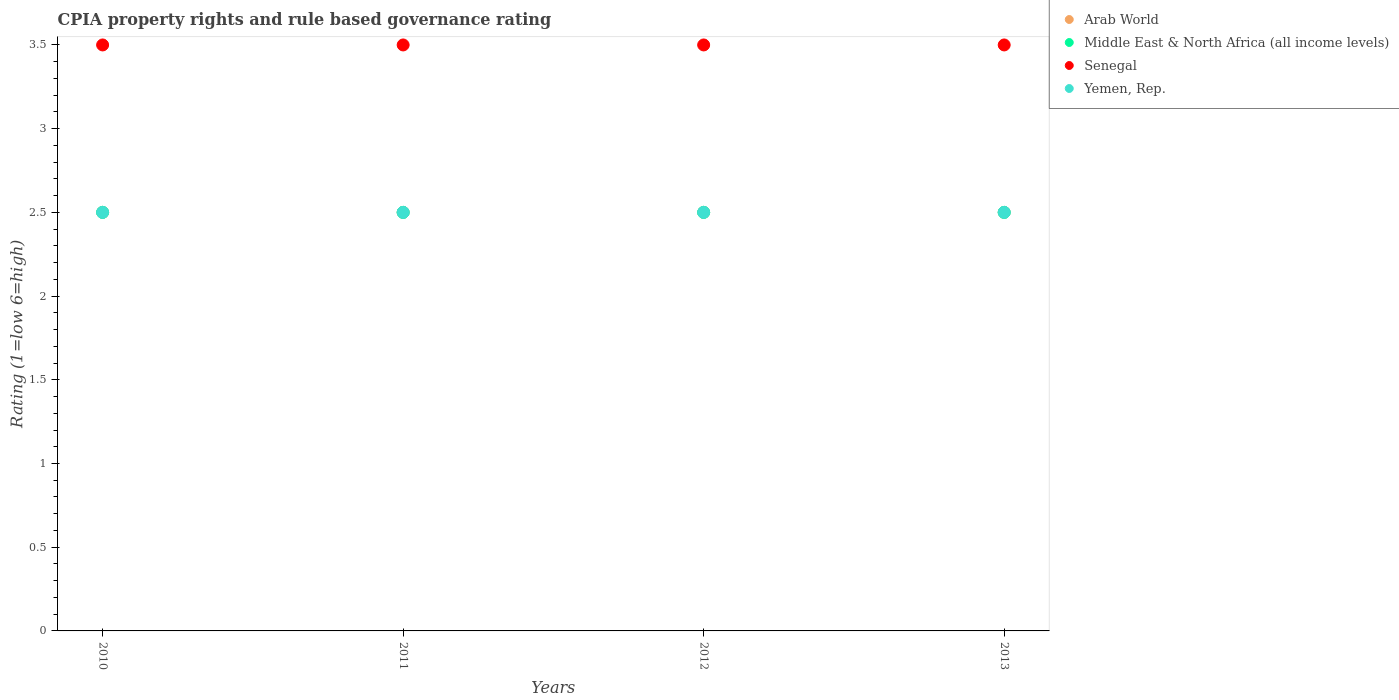Is the number of dotlines equal to the number of legend labels?
Keep it short and to the point. Yes. What is the CPIA rating in Yemen, Rep. in 2011?
Ensure brevity in your answer.  2.5. Across all years, what is the minimum CPIA rating in Senegal?
Ensure brevity in your answer.  3.5. In which year was the CPIA rating in Yemen, Rep. maximum?
Your answer should be compact. 2010. In which year was the CPIA rating in Senegal minimum?
Your answer should be compact. 2010. What is the ratio of the CPIA rating in Arab World in 2012 to that in 2013?
Make the answer very short. 1. Is the CPIA rating in Senegal in 2010 less than that in 2013?
Offer a very short reply. No. Is the difference between the CPIA rating in Yemen, Rep. in 2010 and 2011 greater than the difference between the CPIA rating in Senegal in 2010 and 2011?
Give a very brief answer. No. What is the difference between the highest and the second highest CPIA rating in Middle East & North Africa (all income levels)?
Keep it short and to the point. 0. Is the sum of the CPIA rating in Arab World in 2010 and 2012 greater than the maximum CPIA rating in Yemen, Rep. across all years?
Your answer should be compact. Yes. Does the CPIA rating in Arab World monotonically increase over the years?
Offer a very short reply. No. Is the CPIA rating in Senegal strictly greater than the CPIA rating in Yemen, Rep. over the years?
Ensure brevity in your answer.  Yes. Is the CPIA rating in Senegal strictly less than the CPIA rating in Arab World over the years?
Your response must be concise. No. How many dotlines are there?
Ensure brevity in your answer.  4. Does the graph contain any zero values?
Keep it short and to the point. No. Does the graph contain grids?
Give a very brief answer. No. Where does the legend appear in the graph?
Give a very brief answer. Top right. How many legend labels are there?
Your answer should be compact. 4. How are the legend labels stacked?
Offer a terse response. Vertical. What is the title of the graph?
Keep it short and to the point. CPIA property rights and rule based governance rating. Does "Peru" appear as one of the legend labels in the graph?
Offer a terse response. No. What is the label or title of the Y-axis?
Keep it short and to the point. Rating (1=low 6=high). What is the Rating (1=low 6=high) of Arab World in 2011?
Your response must be concise. 2.5. What is the Rating (1=low 6=high) of Middle East & North Africa (all income levels) in 2011?
Your answer should be compact. 2.5. What is the Rating (1=low 6=high) of Yemen, Rep. in 2011?
Keep it short and to the point. 2.5. What is the Rating (1=low 6=high) of Arab World in 2012?
Keep it short and to the point. 2.5. What is the Rating (1=low 6=high) of Arab World in 2013?
Provide a short and direct response. 2.5. What is the Rating (1=low 6=high) of Middle East & North Africa (all income levels) in 2013?
Give a very brief answer. 2.5. What is the Rating (1=low 6=high) of Senegal in 2013?
Your answer should be compact. 3.5. What is the Rating (1=low 6=high) of Yemen, Rep. in 2013?
Offer a terse response. 2.5. Across all years, what is the maximum Rating (1=low 6=high) of Middle East & North Africa (all income levels)?
Ensure brevity in your answer.  2.5. Across all years, what is the maximum Rating (1=low 6=high) of Senegal?
Provide a succinct answer. 3.5. Across all years, what is the maximum Rating (1=low 6=high) in Yemen, Rep.?
Provide a succinct answer. 2.5. Across all years, what is the minimum Rating (1=low 6=high) in Middle East & North Africa (all income levels)?
Provide a succinct answer. 2.5. Across all years, what is the minimum Rating (1=low 6=high) of Senegal?
Your answer should be very brief. 3.5. Across all years, what is the minimum Rating (1=low 6=high) in Yemen, Rep.?
Make the answer very short. 2.5. What is the total Rating (1=low 6=high) in Arab World in the graph?
Your response must be concise. 10. What is the difference between the Rating (1=low 6=high) of Middle East & North Africa (all income levels) in 2010 and that in 2011?
Offer a very short reply. 0. What is the difference between the Rating (1=low 6=high) of Arab World in 2010 and that in 2013?
Offer a terse response. 0. What is the difference between the Rating (1=low 6=high) of Senegal in 2010 and that in 2013?
Make the answer very short. 0. What is the difference between the Rating (1=low 6=high) in Arab World in 2011 and that in 2012?
Your response must be concise. 0. What is the difference between the Rating (1=low 6=high) of Middle East & North Africa (all income levels) in 2011 and that in 2012?
Your answer should be very brief. 0. What is the difference between the Rating (1=low 6=high) of Senegal in 2011 and that in 2012?
Provide a succinct answer. 0. What is the difference between the Rating (1=low 6=high) in Arab World in 2011 and that in 2013?
Your response must be concise. 0. What is the difference between the Rating (1=low 6=high) of Middle East & North Africa (all income levels) in 2011 and that in 2013?
Your answer should be very brief. 0. What is the difference between the Rating (1=low 6=high) of Senegal in 2011 and that in 2013?
Keep it short and to the point. 0. What is the difference between the Rating (1=low 6=high) of Yemen, Rep. in 2011 and that in 2013?
Your answer should be compact. 0. What is the difference between the Rating (1=low 6=high) of Middle East & North Africa (all income levels) in 2012 and that in 2013?
Offer a very short reply. 0. What is the difference between the Rating (1=low 6=high) of Senegal in 2012 and that in 2013?
Provide a succinct answer. 0. What is the difference between the Rating (1=low 6=high) in Yemen, Rep. in 2012 and that in 2013?
Provide a short and direct response. 0. What is the difference between the Rating (1=low 6=high) of Arab World in 2010 and the Rating (1=low 6=high) of Middle East & North Africa (all income levels) in 2011?
Offer a very short reply. 0. What is the difference between the Rating (1=low 6=high) in Arab World in 2010 and the Rating (1=low 6=high) in Middle East & North Africa (all income levels) in 2012?
Offer a very short reply. 0. What is the difference between the Rating (1=low 6=high) of Arab World in 2010 and the Rating (1=low 6=high) of Senegal in 2012?
Keep it short and to the point. -1. What is the difference between the Rating (1=low 6=high) in Arab World in 2010 and the Rating (1=low 6=high) in Yemen, Rep. in 2012?
Offer a terse response. 0. What is the difference between the Rating (1=low 6=high) of Middle East & North Africa (all income levels) in 2010 and the Rating (1=low 6=high) of Senegal in 2012?
Ensure brevity in your answer.  -1. What is the difference between the Rating (1=low 6=high) in Middle East & North Africa (all income levels) in 2010 and the Rating (1=low 6=high) in Yemen, Rep. in 2012?
Ensure brevity in your answer.  0. What is the difference between the Rating (1=low 6=high) of Senegal in 2010 and the Rating (1=low 6=high) of Yemen, Rep. in 2012?
Provide a short and direct response. 1. What is the difference between the Rating (1=low 6=high) of Arab World in 2010 and the Rating (1=low 6=high) of Yemen, Rep. in 2013?
Your answer should be compact. 0. What is the difference between the Rating (1=low 6=high) in Middle East & North Africa (all income levels) in 2010 and the Rating (1=low 6=high) in Senegal in 2013?
Give a very brief answer. -1. What is the difference between the Rating (1=low 6=high) of Arab World in 2011 and the Rating (1=low 6=high) of Middle East & North Africa (all income levels) in 2012?
Provide a short and direct response. 0. What is the difference between the Rating (1=low 6=high) of Arab World in 2011 and the Rating (1=low 6=high) of Yemen, Rep. in 2012?
Your answer should be very brief. 0. What is the difference between the Rating (1=low 6=high) in Middle East & North Africa (all income levels) in 2011 and the Rating (1=low 6=high) in Senegal in 2012?
Your response must be concise. -1. What is the difference between the Rating (1=low 6=high) in Middle East & North Africa (all income levels) in 2011 and the Rating (1=low 6=high) in Yemen, Rep. in 2012?
Provide a succinct answer. 0. What is the difference between the Rating (1=low 6=high) of Senegal in 2011 and the Rating (1=low 6=high) of Yemen, Rep. in 2012?
Your answer should be very brief. 1. What is the difference between the Rating (1=low 6=high) in Arab World in 2011 and the Rating (1=low 6=high) in Middle East & North Africa (all income levels) in 2013?
Give a very brief answer. 0. What is the difference between the Rating (1=low 6=high) of Middle East & North Africa (all income levels) in 2011 and the Rating (1=low 6=high) of Senegal in 2013?
Your answer should be very brief. -1. What is the difference between the Rating (1=low 6=high) in Middle East & North Africa (all income levels) in 2011 and the Rating (1=low 6=high) in Yemen, Rep. in 2013?
Provide a succinct answer. 0. What is the difference between the Rating (1=low 6=high) in Senegal in 2011 and the Rating (1=low 6=high) in Yemen, Rep. in 2013?
Make the answer very short. 1. What is the difference between the Rating (1=low 6=high) of Arab World in 2012 and the Rating (1=low 6=high) of Yemen, Rep. in 2013?
Offer a terse response. 0. What is the difference between the Rating (1=low 6=high) in Middle East & North Africa (all income levels) in 2012 and the Rating (1=low 6=high) in Senegal in 2013?
Provide a short and direct response. -1. What is the average Rating (1=low 6=high) in Middle East & North Africa (all income levels) per year?
Provide a short and direct response. 2.5. What is the average Rating (1=low 6=high) in Senegal per year?
Keep it short and to the point. 3.5. What is the average Rating (1=low 6=high) in Yemen, Rep. per year?
Keep it short and to the point. 2.5. In the year 2010, what is the difference between the Rating (1=low 6=high) in Arab World and Rating (1=low 6=high) in Middle East & North Africa (all income levels)?
Your response must be concise. 0. In the year 2010, what is the difference between the Rating (1=low 6=high) of Arab World and Rating (1=low 6=high) of Yemen, Rep.?
Provide a short and direct response. 0. In the year 2010, what is the difference between the Rating (1=low 6=high) in Senegal and Rating (1=low 6=high) in Yemen, Rep.?
Provide a succinct answer. 1. In the year 2011, what is the difference between the Rating (1=low 6=high) of Arab World and Rating (1=low 6=high) of Senegal?
Your answer should be very brief. -1. In the year 2011, what is the difference between the Rating (1=low 6=high) in Arab World and Rating (1=low 6=high) in Yemen, Rep.?
Ensure brevity in your answer.  0. In the year 2011, what is the difference between the Rating (1=low 6=high) of Middle East & North Africa (all income levels) and Rating (1=low 6=high) of Senegal?
Make the answer very short. -1. In the year 2011, what is the difference between the Rating (1=low 6=high) in Middle East & North Africa (all income levels) and Rating (1=low 6=high) in Yemen, Rep.?
Ensure brevity in your answer.  0. In the year 2011, what is the difference between the Rating (1=low 6=high) in Senegal and Rating (1=low 6=high) in Yemen, Rep.?
Your response must be concise. 1. In the year 2012, what is the difference between the Rating (1=low 6=high) of Arab World and Rating (1=low 6=high) of Yemen, Rep.?
Ensure brevity in your answer.  0. In the year 2012, what is the difference between the Rating (1=low 6=high) of Middle East & North Africa (all income levels) and Rating (1=low 6=high) of Senegal?
Offer a very short reply. -1. In the year 2013, what is the difference between the Rating (1=low 6=high) of Arab World and Rating (1=low 6=high) of Senegal?
Give a very brief answer. -1. In the year 2013, what is the difference between the Rating (1=low 6=high) in Middle East & North Africa (all income levels) and Rating (1=low 6=high) in Senegal?
Offer a terse response. -1. What is the ratio of the Rating (1=low 6=high) of Arab World in 2010 to that in 2011?
Ensure brevity in your answer.  1. What is the ratio of the Rating (1=low 6=high) of Senegal in 2010 to that in 2011?
Make the answer very short. 1. What is the ratio of the Rating (1=low 6=high) in Yemen, Rep. in 2010 to that in 2011?
Ensure brevity in your answer.  1. What is the ratio of the Rating (1=low 6=high) of Middle East & North Africa (all income levels) in 2010 to that in 2012?
Offer a very short reply. 1. What is the ratio of the Rating (1=low 6=high) in Senegal in 2010 to that in 2012?
Offer a terse response. 1. What is the ratio of the Rating (1=low 6=high) in Arab World in 2010 to that in 2013?
Your response must be concise. 1. What is the ratio of the Rating (1=low 6=high) of Middle East & North Africa (all income levels) in 2010 to that in 2013?
Your answer should be very brief. 1. What is the ratio of the Rating (1=low 6=high) in Arab World in 2011 to that in 2012?
Give a very brief answer. 1. What is the ratio of the Rating (1=low 6=high) in Senegal in 2011 to that in 2012?
Ensure brevity in your answer.  1. What is the ratio of the Rating (1=low 6=high) of Middle East & North Africa (all income levels) in 2012 to that in 2013?
Make the answer very short. 1. What is the ratio of the Rating (1=low 6=high) in Yemen, Rep. in 2012 to that in 2013?
Offer a very short reply. 1. What is the difference between the highest and the second highest Rating (1=low 6=high) of Arab World?
Your answer should be very brief. 0. What is the difference between the highest and the second highest Rating (1=low 6=high) in Yemen, Rep.?
Make the answer very short. 0. What is the difference between the highest and the lowest Rating (1=low 6=high) in Middle East & North Africa (all income levels)?
Keep it short and to the point. 0. 